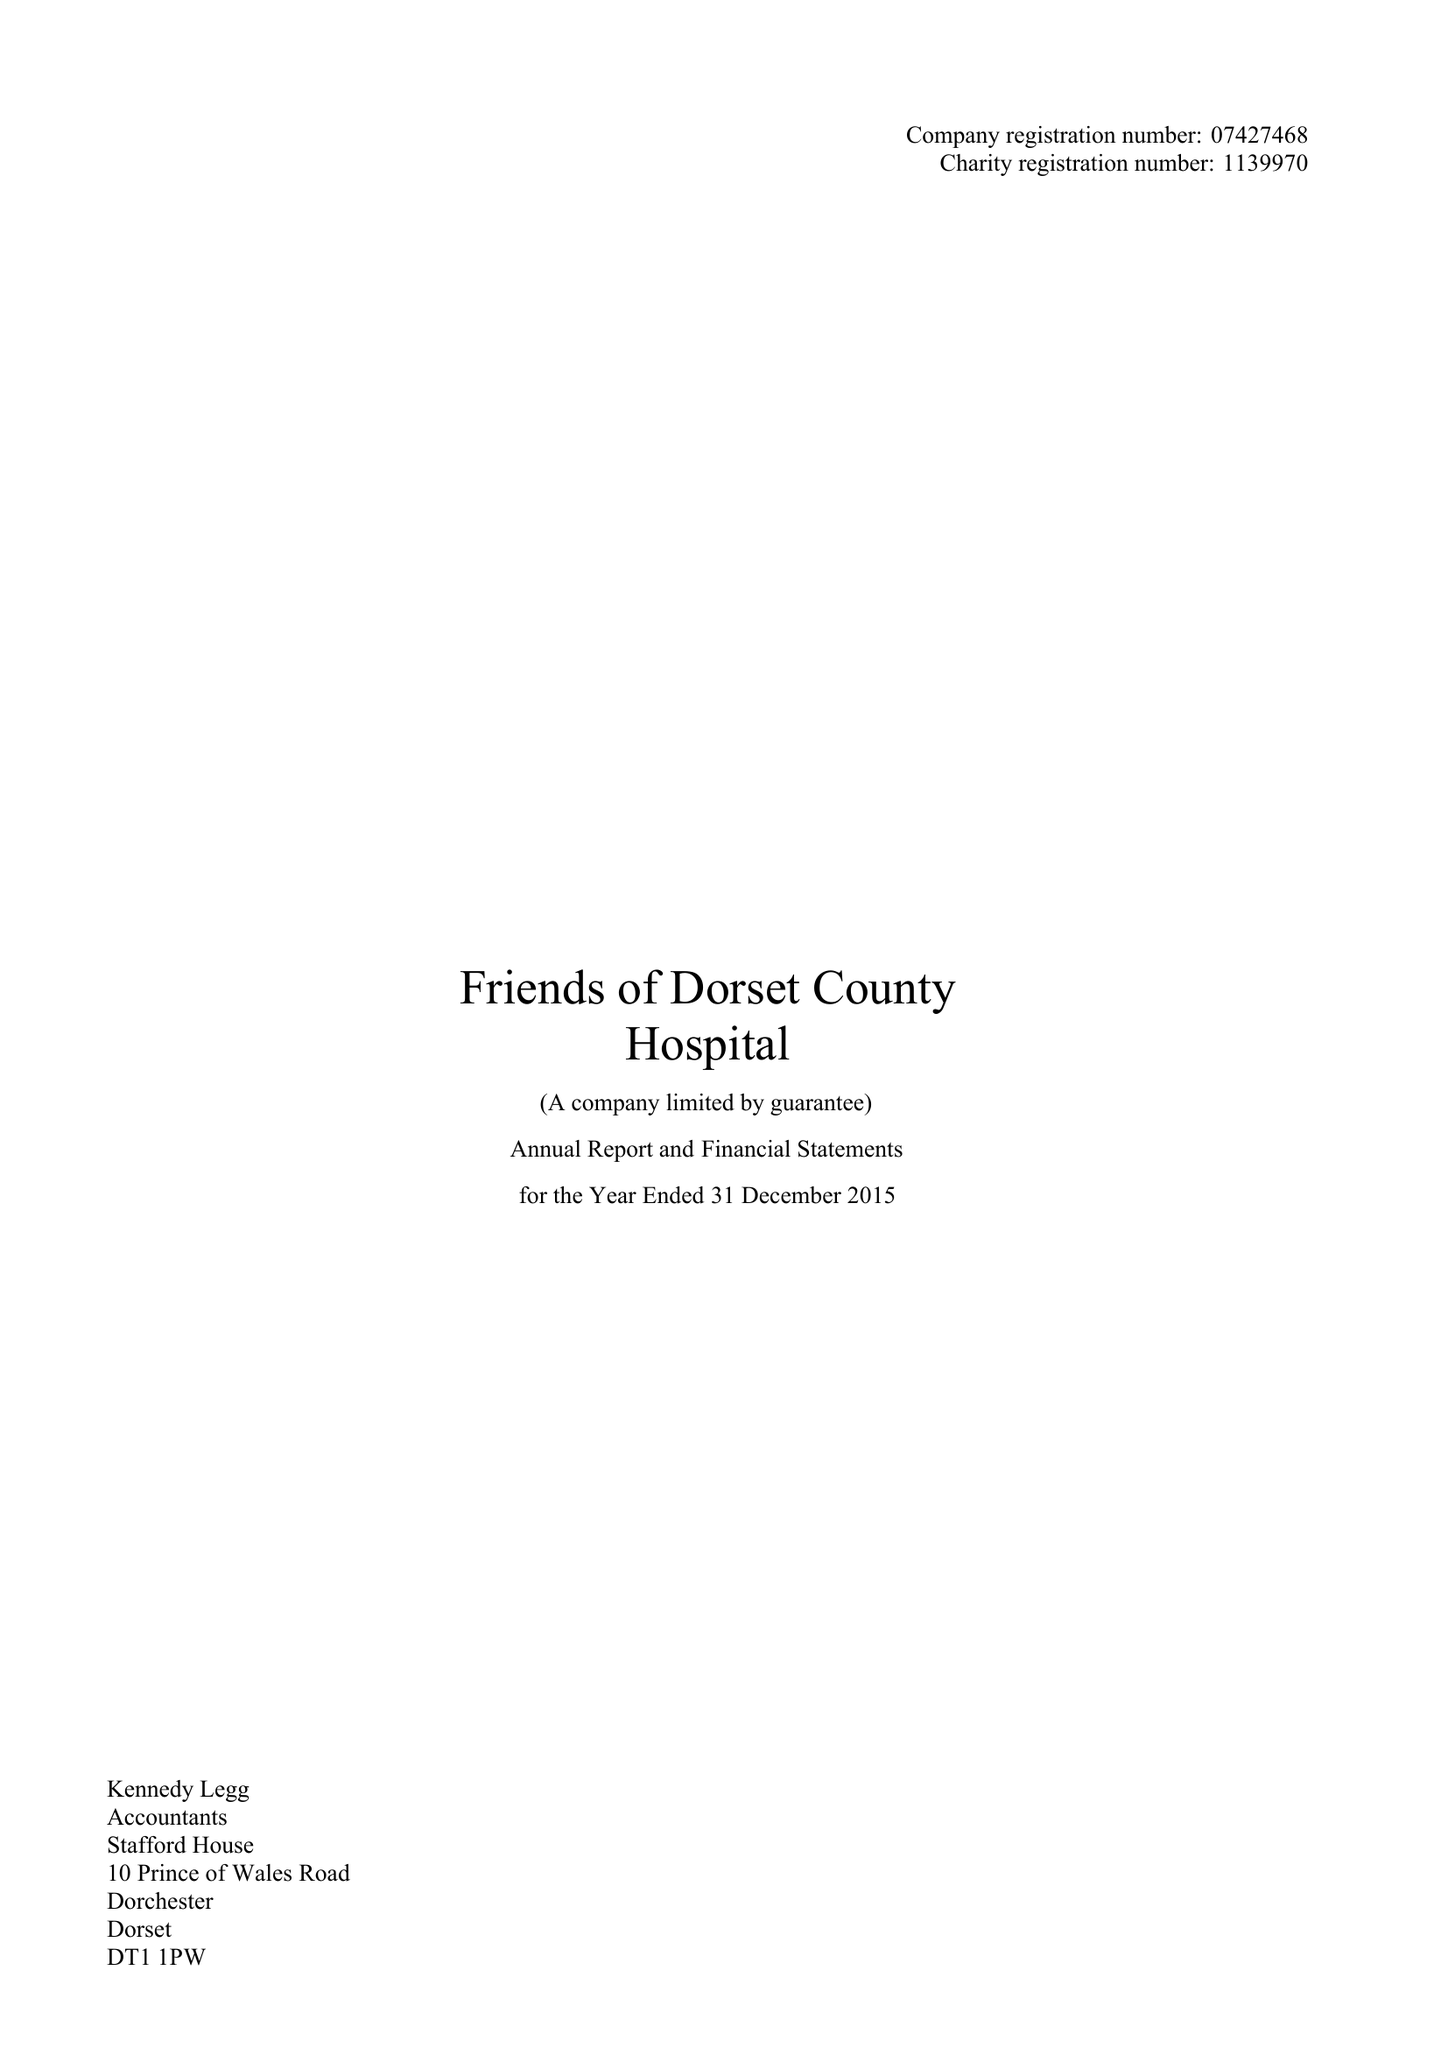What is the value for the address__street_line?
Answer the question using a single word or phrase. PRINCE OF WALES ROAD 